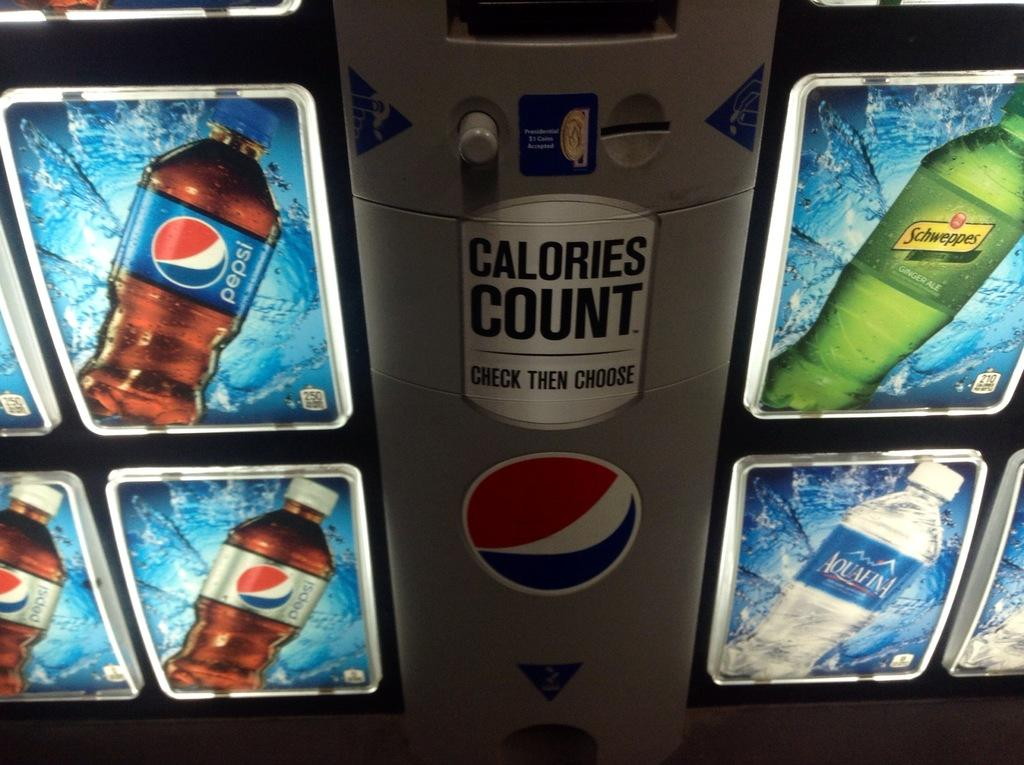<image>
Write a terse but informative summary of the picture. A Pepsi vending machine that also sells Aquafina water. 